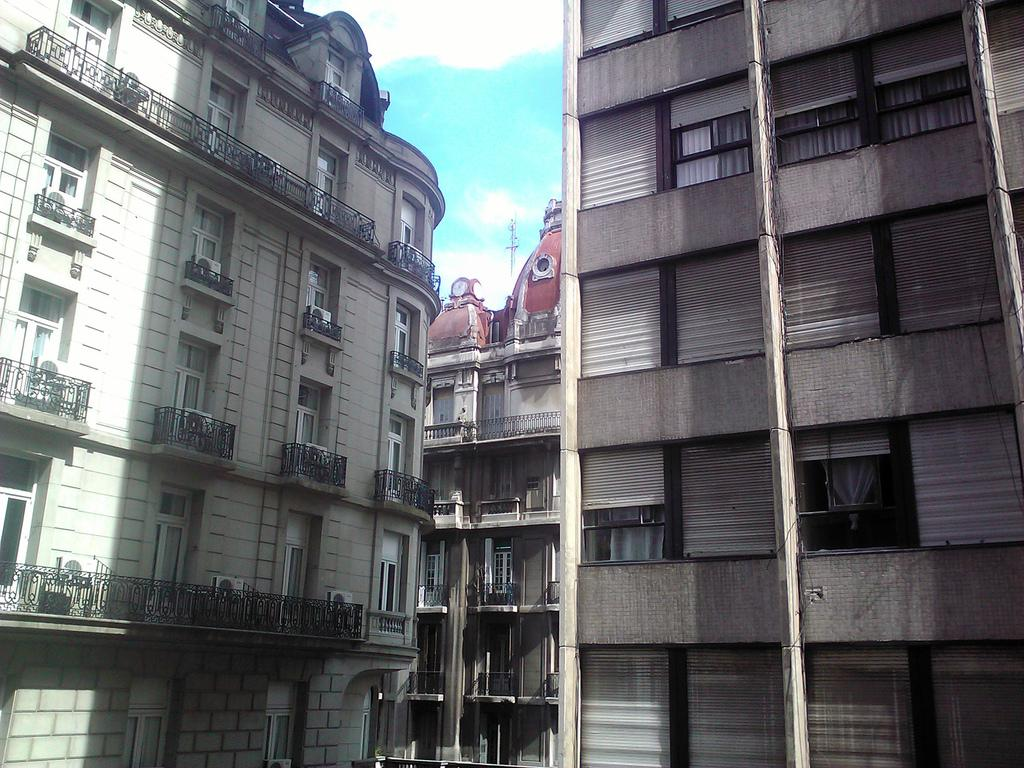What type of structures are in the image? There are buildings in the image. What features can be seen on the buildings? The buildings have windows and curtains. What is visible in the background of the image? The sky is visible in the background of the image. What can be observed in the sky? Clouds are present in the sky. What type of company is being advertised on the buildings in the image? There is no company being advertised on the buildings in the image. What type of vacation destination is depicted in the image? There is no vacation destination depicted in the image; it features buildings with windows and curtains, as well as a sky with clouds. 